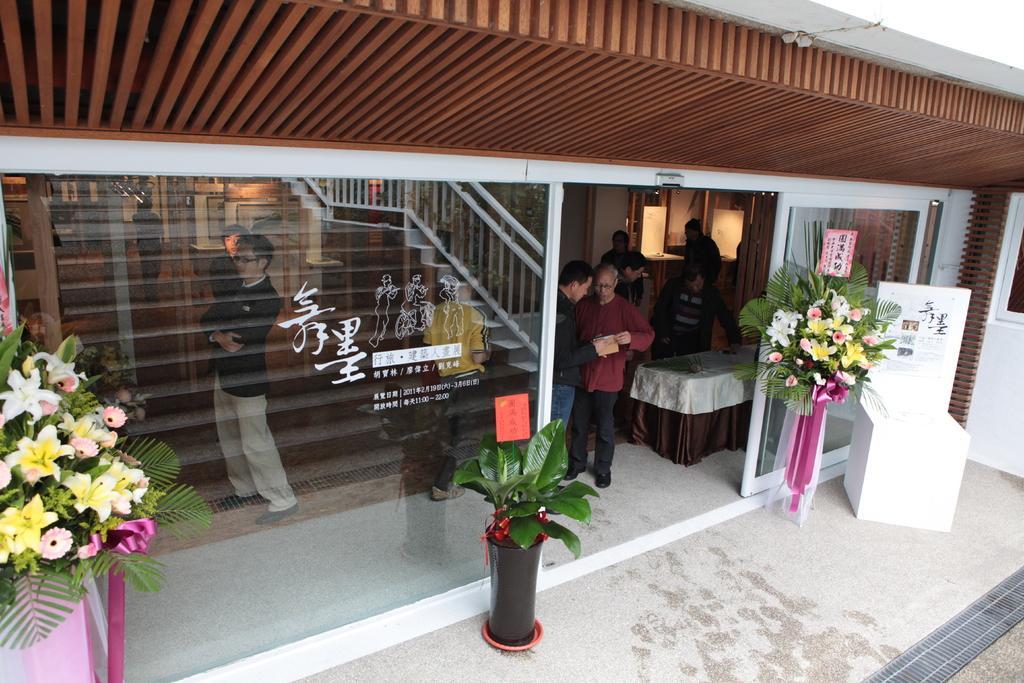Describe this image in one or two sentences. In this image center there is a building and in the building there are some people standing and there are some tables, and there is a staircase and glass doors. And in the foreground there are objects and some flower bouquets and there is one white color box, and some cards. At the bottom there is walkway. 